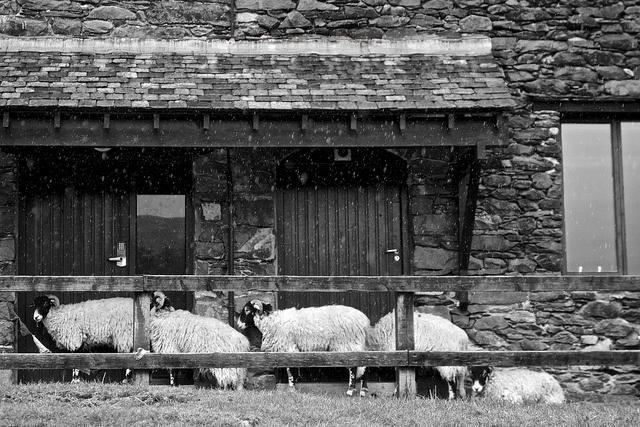Describe the objects in this image and their specific colors. I can see sheep in black, lightgray, darkgray, and gray tones, sheep in black, lightgray, darkgray, and gray tones, sheep in black, lightgray, darkgray, and gray tones, sheep in black, lightgray, darkgray, and gray tones, and sheep in black, lightgray, darkgray, and dimgray tones in this image. 